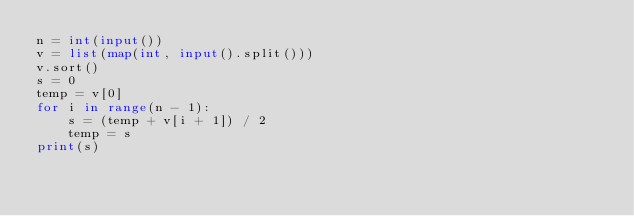Convert code to text. <code><loc_0><loc_0><loc_500><loc_500><_Python_>n = int(input())
v = list(map(int, input().split()))
v.sort()
s = 0
temp = v[0]
for i in range(n - 1):
    s = (temp + v[i + 1]) / 2
    temp = s
print(s)
</code> 